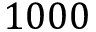Convert formula to latex. <formula><loc_0><loc_0><loc_500><loc_500>1 0 0 0</formula> 